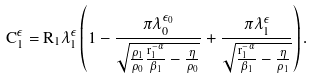Convert formula to latex. <formula><loc_0><loc_0><loc_500><loc_500>C _ { 1 } ^ { \epsilon } = R _ { 1 } \lambda _ { 1 } ^ { \epsilon } \left ( 1 - \frac { \pi \lambda _ { 0 } ^ { \epsilon _ { 0 } } } { \sqrt { \frac { \rho _ { 1 } } { \rho _ { 0 } } \frac { r _ { 1 } ^ { - \alpha } } { \beta _ { 1 } } - \frac { \eta } { \rho _ { 0 } } } } + \frac { \pi \lambda _ { 1 } ^ { \epsilon } } { \sqrt { \frac { r _ { 1 } ^ { - \alpha } } { \beta _ { 1 } } - \frac { \eta } { \rho _ { 1 } } } } \right ) .</formula> 